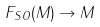Convert formula to latex. <formula><loc_0><loc_0><loc_500><loc_500>F _ { S O } ( M ) \rightarrow M</formula> 